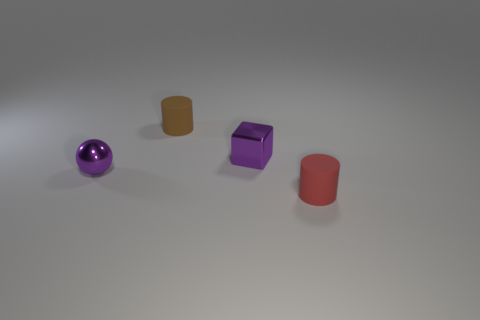Add 1 red rubber cylinders. How many objects exist? 5 Subtract all balls. How many objects are left? 3 Subtract all large green metal cubes. Subtract all tiny purple objects. How many objects are left? 2 Add 1 tiny metallic things. How many tiny metallic things are left? 3 Add 4 purple cubes. How many purple cubes exist? 5 Subtract 1 purple balls. How many objects are left? 3 